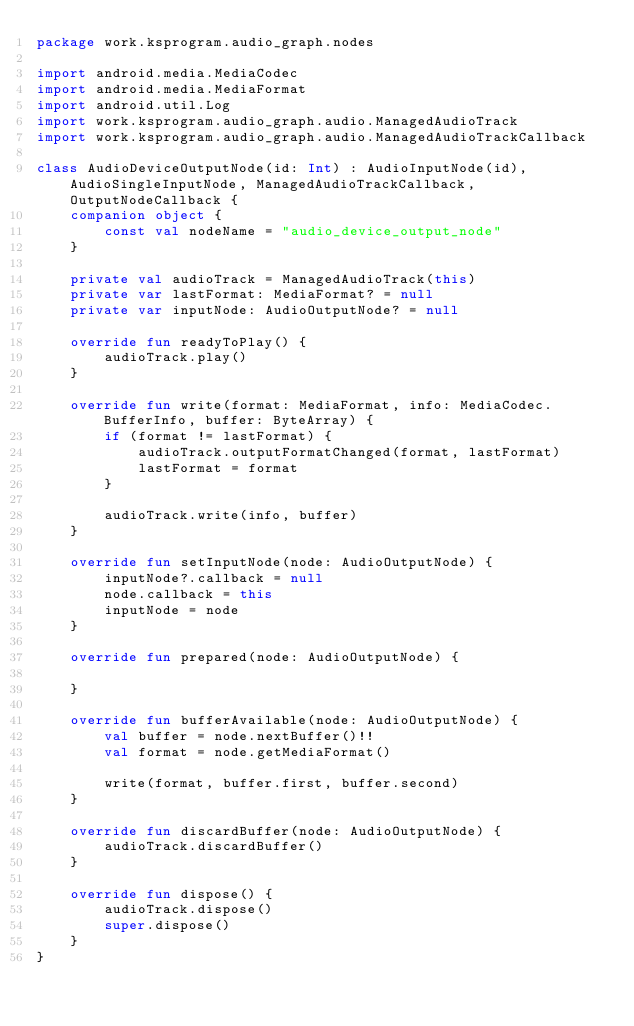<code> <loc_0><loc_0><loc_500><loc_500><_Kotlin_>package work.ksprogram.audio_graph.nodes

import android.media.MediaCodec
import android.media.MediaFormat
import android.util.Log
import work.ksprogram.audio_graph.audio.ManagedAudioTrack
import work.ksprogram.audio_graph.audio.ManagedAudioTrackCallback

class AudioDeviceOutputNode(id: Int) : AudioInputNode(id), AudioSingleInputNode, ManagedAudioTrackCallback, OutputNodeCallback {
    companion object {
        const val nodeName = "audio_device_output_node"
    }

    private val audioTrack = ManagedAudioTrack(this)
    private var lastFormat: MediaFormat? = null
    private var inputNode: AudioOutputNode? = null

    override fun readyToPlay() {
        audioTrack.play()
    }

    override fun write(format: MediaFormat, info: MediaCodec.BufferInfo, buffer: ByteArray) {
        if (format != lastFormat) {
            audioTrack.outputFormatChanged(format, lastFormat)
            lastFormat = format
        }

        audioTrack.write(info, buffer)
    }

    override fun setInputNode(node: AudioOutputNode) {
        inputNode?.callback = null
        node.callback = this
        inputNode = node
    }

    override fun prepared(node: AudioOutputNode) {

    }

    override fun bufferAvailable(node: AudioOutputNode) {
        val buffer = node.nextBuffer()!!
        val format = node.getMediaFormat()

        write(format, buffer.first, buffer.second)
    }

    override fun discardBuffer(node: AudioOutputNode) {
        audioTrack.discardBuffer()
    }

    override fun dispose() {
        audioTrack.dispose()
        super.dispose()
    }
}</code> 